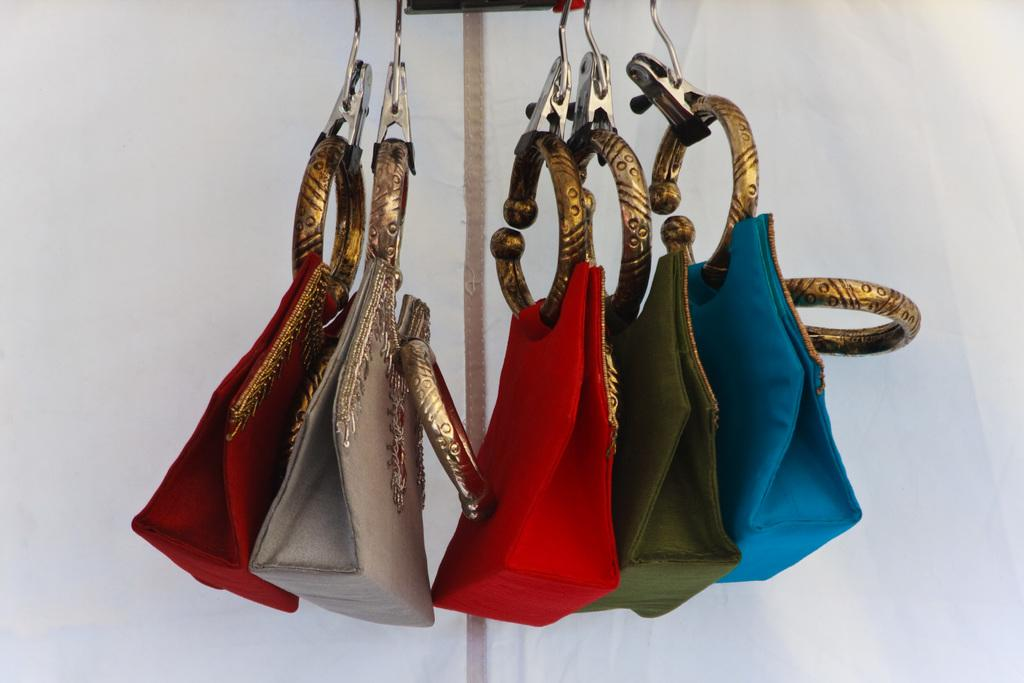How many handbags are visible in the image? There are five handbags in the image. Can you describe the appearance of the handbags? The handbags are colorful. How are the handbags positioned in the image? The handbags are hanging from a rod. What idea does the alley have about the handbags in the image? There is no alley or any other sentient being mentioned in the image, so it is not possible to determine any ideas they might have about the handbags. 